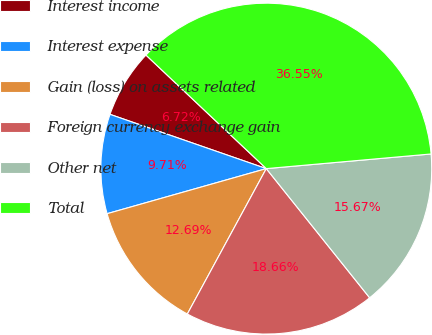<chart> <loc_0><loc_0><loc_500><loc_500><pie_chart><fcel>Interest income<fcel>Interest expense<fcel>Gain (loss) on assets related<fcel>Foreign currency exchange gain<fcel>Other net<fcel>Total<nl><fcel>6.72%<fcel>9.71%<fcel>12.69%<fcel>18.66%<fcel>15.67%<fcel>36.55%<nl></chart> 